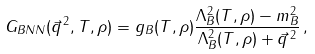Convert formula to latex. <formula><loc_0><loc_0><loc_500><loc_500>G _ { B N N } ( \vec { q } ^ { \, 2 } , T , \rho ) = g _ { B } ( T , \rho ) \frac { \Lambda ^ { 2 } _ { B } ( T , \rho ) - m ^ { 2 } _ { B } } { \Lambda ^ { 2 } _ { B } ( T , \rho ) + \vec { q } ^ { \, 2 } } \, ,</formula> 